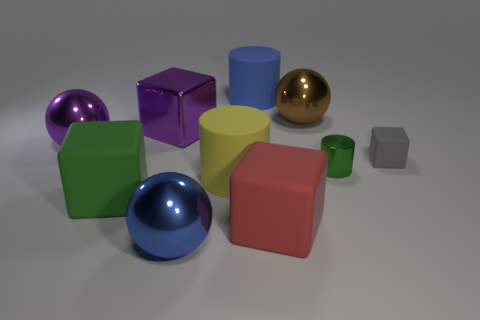How many big brown rubber cylinders are there?
Provide a short and direct response. 0. Does the big yellow matte thing have the same shape as the big blue object on the right side of the big blue metallic ball?
Your response must be concise. Yes. What is the size of the rubber thing that is left of the large blue sphere?
Give a very brief answer. Large. What is the green cylinder made of?
Your answer should be very brief. Metal. Do the purple shiny thing that is right of the large purple sphere and the blue matte object have the same shape?
Offer a very short reply. No. The rubber thing that is the same color as the tiny metallic thing is what size?
Keep it short and to the point. Large. Is there another blue cube that has the same size as the shiny block?
Your answer should be very brief. No. There is a blue object behind the ball that is in front of the gray block; is there a large brown object that is behind it?
Provide a succinct answer. No. Does the tiny matte object have the same color as the big cylinder that is behind the tiny gray matte cube?
Your answer should be compact. No. What material is the big block behind the matte cylinder in front of the blue matte thing that is behind the big brown shiny ball?
Provide a succinct answer. Metal. 